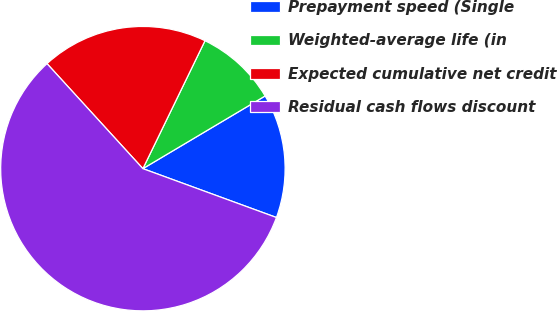Convert chart. <chart><loc_0><loc_0><loc_500><loc_500><pie_chart><fcel>Prepayment speed (Single<fcel>Weighted-average life (in<fcel>Expected cumulative net credit<fcel>Residual cash flows discount<nl><fcel>14.12%<fcel>9.27%<fcel>18.97%<fcel>57.64%<nl></chart> 